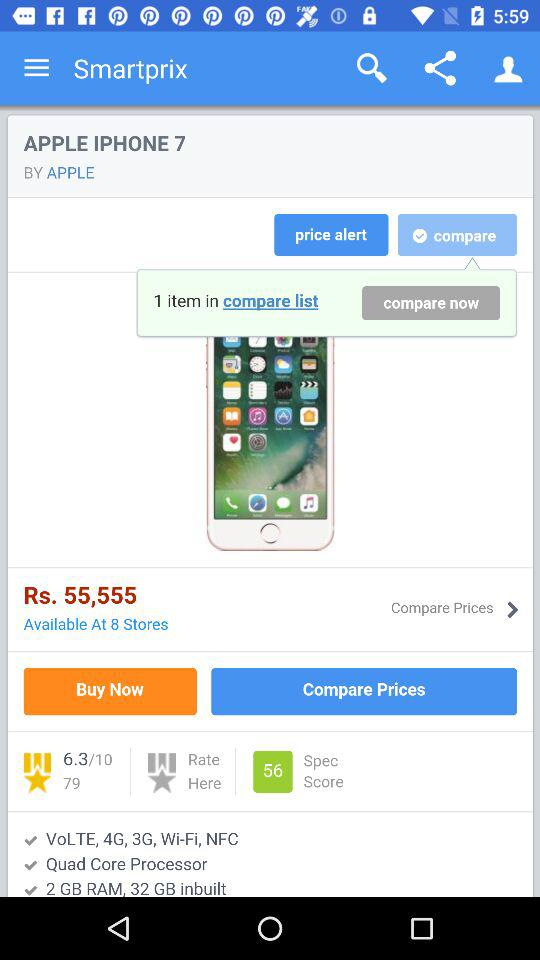What processor is installed in the iPhone 7? The processor is a "Quad Core Processor". 